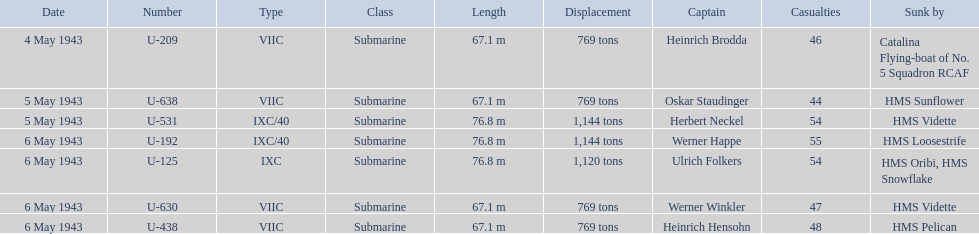What was the only captain sunk by hms pelican? Heinrich Hensohn. 